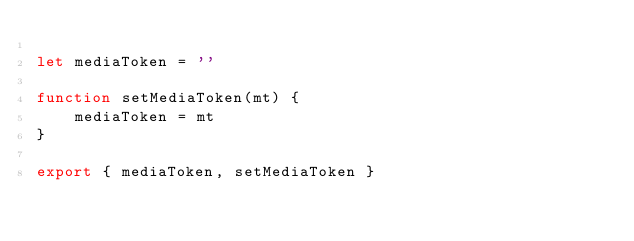<code> <loc_0><loc_0><loc_500><loc_500><_TypeScript_>
let mediaToken = ''

function setMediaToken(mt) {
    mediaToken = mt
}

export { mediaToken, setMediaToken }
</code> 